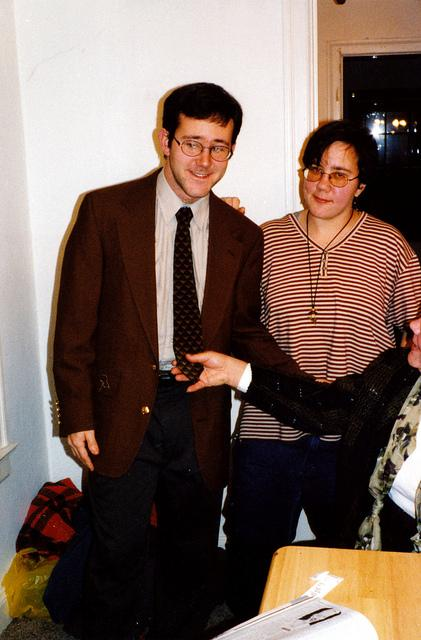What is sometimes substituted for the item the woman is holding? bowtie 